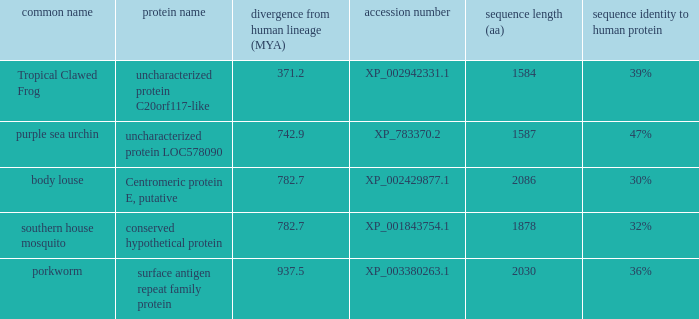What is the designation of the protein with a sequence similarity to human protein of 32%? Conserved hypothetical protein. 